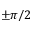<formula> <loc_0><loc_0><loc_500><loc_500>\pm \pi / 2</formula> 